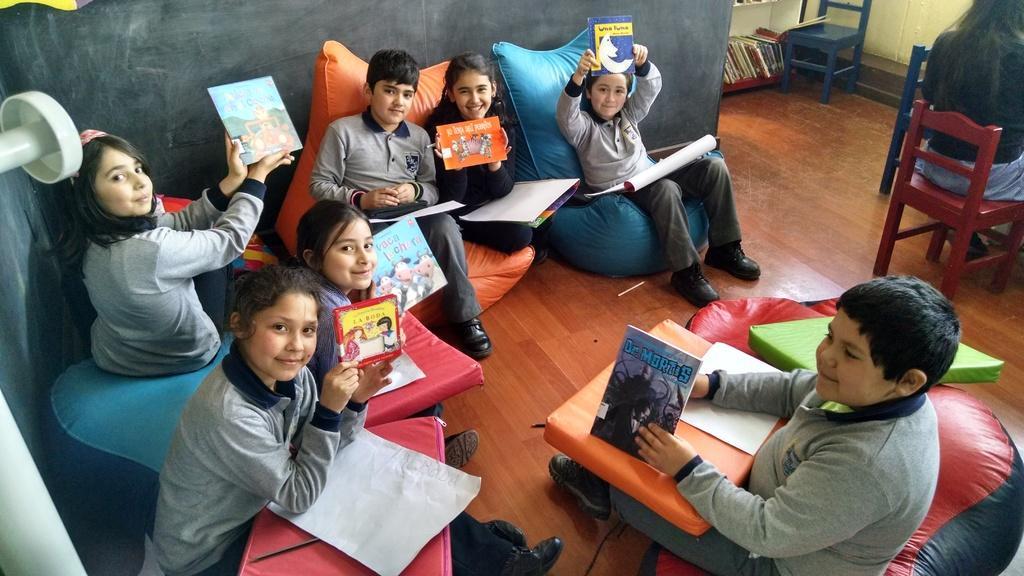In one or two sentences, can you explain what this image depicts? In this picture we can see a group of children sitting on bean bags and holding books with their hands and smiling and in the background we can see chairs, books and a woman sitting on a chair. 